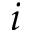Convert formula to latex. <formula><loc_0><loc_0><loc_500><loc_500>i</formula> 